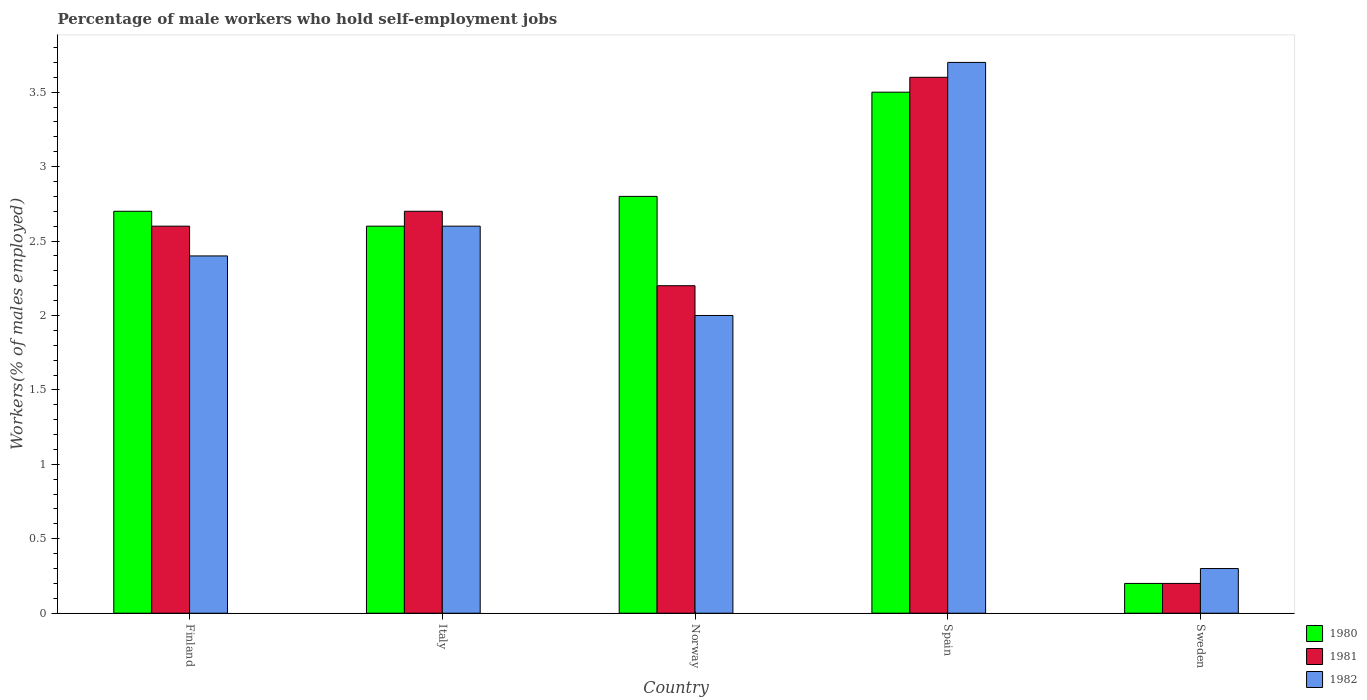How many groups of bars are there?
Your answer should be very brief. 5. In how many cases, is the number of bars for a given country not equal to the number of legend labels?
Keep it short and to the point. 0. What is the percentage of self-employed male workers in 1980 in Finland?
Your response must be concise. 2.7. Across all countries, what is the maximum percentage of self-employed male workers in 1982?
Offer a terse response. 3.7. Across all countries, what is the minimum percentage of self-employed male workers in 1980?
Offer a terse response. 0.2. In which country was the percentage of self-employed male workers in 1980 maximum?
Give a very brief answer. Spain. What is the total percentage of self-employed male workers in 1982 in the graph?
Keep it short and to the point. 11. What is the difference between the percentage of self-employed male workers in 1980 in Finland and that in Sweden?
Give a very brief answer. 2.5. What is the average percentage of self-employed male workers in 1980 per country?
Your answer should be very brief. 2.36. What is the ratio of the percentage of self-employed male workers in 1980 in Norway to that in Sweden?
Your response must be concise. 14. Is the difference between the percentage of self-employed male workers in 1980 in Finland and Norway greater than the difference between the percentage of self-employed male workers in 1982 in Finland and Norway?
Provide a short and direct response. No. What is the difference between the highest and the second highest percentage of self-employed male workers in 1982?
Provide a short and direct response. -1.1. What is the difference between the highest and the lowest percentage of self-employed male workers in 1982?
Your response must be concise. 3.4. In how many countries, is the percentage of self-employed male workers in 1981 greater than the average percentage of self-employed male workers in 1981 taken over all countries?
Your answer should be very brief. 3. Is the sum of the percentage of self-employed male workers in 1981 in Finland and Norway greater than the maximum percentage of self-employed male workers in 1980 across all countries?
Your response must be concise. Yes. Is it the case that in every country, the sum of the percentage of self-employed male workers in 1982 and percentage of self-employed male workers in 1981 is greater than the percentage of self-employed male workers in 1980?
Provide a succinct answer. Yes. How many bars are there?
Provide a short and direct response. 15. Are all the bars in the graph horizontal?
Make the answer very short. No. How many countries are there in the graph?
Your answer should be very brief. 5. What is the difference between two consecutive major ticks on the Y-axis?
Provide a succinct answer. 0.5. Are the values on the major ticks of Y-axis written in scientific E-notation?
Provide a short and direct response. No. Does the graph contain any zero values?
Provide a succinct answer. No. Does the graph contain grids?
Provide a short and direct response. No. Where does the legend appear in the graph?
Make the answer very short. Bottom right. What is the title of the graph?
Make the answer very short. Percentage of male workers who hold self-employment jobs. What is the label or title of the Y-axis?
Your response must be concise. Workers(% of males employed). What is the Workers(% of males employed) of 1980 in Finland?
Offer a very short reply. 2.7. What is the Workers(% of males employed) of 1981 in Finland?
Offer a very short reply. 2.6. What is the Workers(% of males employed) in 1982 in Finland?
Your answer should be very brief. 2.4. What is the Workers(% of males employed) of 1980 in Italy?
Provide a short and direct response. 2.6. What is the Workers(% of males employed) of 1981 in Italy?
Ensure brevity in your answer.  2.7. What is the Workers(% of males employed) in 1982 in Italy?
Give a very brief answer. 2.6. What is the Workers(% of males employed) in 1980 in Norway?
Your answer should be compact. 2.8. What is the Workers(% of males employed) in 1981 in Norway?
Your answer should be very brief. 2.2. What is the Workers(% of males employed) of 1982 in Norway?
Make the answer very short. 2. What is the Workers(% of males employed) in 1981 in Spain?
Your response must be concise. 3.6. What is the Workers(% of males employed) of 1982 in Spain?
Offer a terse response. 3.7. What is the Workers(% of males employed) in 1980 in Sweden?
Offer a very short reply. 0.2. What is the Workers(% of males employed) of 1981 in Sweden?
Give a very brief answer. 0.2. What is the Workers(% of males employed) of 1982 in Sweden?
Offer a very short reply. 0.3. Across all countries, what is the maximum Workers(% of males employed) of 1981?
Offer a very short reply. 3.6. Across all countries, what is the maximum Workers(% of males employed) in 1982?
Keep it short and to the point. 3.7. Across all countries, what is the minimum Workers(% of males employed) in 1980?
Make the answer very short. 0.2. Across all countries, what is the minimum Workers(% of males employed) of 1981?
Your answer should be compact. 0.2. Across all countries, what is the minimum Workers(% of males employed) of 1982?
Provide a short and direct response. 0.3. What is the total Workers(% of males employed) in 1980 in the graph?
Your answer should be very brief. 11.8. What is the total Workers(% of males employed) in 1982 in the graph?
Your answer should be compact. 11. What is the difference between the Workers(% of males employed) in 1981 in Finland and that in Italy?
Your answer should be compact. -0.1. What is the difference between the Workers(% of males employed) of 1980 in Finland and that in Norway?
Your response must be concise. -0.1. What is the difference between the Workers(% of males employed) in 1982 in Finland and that in Norway?
Offer a terse response. 0.4. What is the difference between the Workers(% of males employed) of 1980 in Finland and that in Spain?
Keep it short and to the point. -0.8. What is the difference between the Workers(% of males employed) of 1981 in Finland and that in Spain?
Your answer should be compact. -1. What is the difference between the Workers(% of males employed) in 1982 in Finland and that in Spain?
Your answer should be compact. -1.3. What is the difference between the Workers(% of males employed) of 1980 in Finland and that in Sweden?
Give a very brief answer. 2.5. What is the difference between the Workers(% of males employed) of 1981 in Finland and that in Sweden?
Provide a short and direct response. 2.4. What is the difference between the Workers(% of males employed) in 1982 in Finland and that in Sweden?
Make the answer very short. 2.1. What is the difference between the Workers(% of males employed) of 1981 in Italy and that in Norway?
Your answer should be very brief. 0.5. What is the difference between the Workers(% of males employed) in 1982 in Italy and that in Norway?
Your response must be concise. 0.6. What is the difference between the Workers(% of males employed) in 1980 in Italy and that in Spain?
Your answer should be compact. -0.9. What is the difference between the Workers(% of males employed) of 1981 in Italy and that in Spain?
Make the answer very short. -0.9. What is the difference between the Workers(% of males employed) of 1981 in Italy and that in Sweden?
Give a very brief answer. 2.5. What is the difference between the Workers(% of males employed) of 1981 in Norway and that in Spain?
Ensure brevity in your answer.  -1.4. What is the difference between the Workers(% of males employed) of 1982 in Norway and that in Spain?
Ensure brevity in your answer.  -1.7. What is the difference between the Workers(% of males employed) of 1981 in Norway and that in Sweden?
Your answer should be very brief. 2. What is the difference between the Workers(% of males employed) in 1981 in Spain and that in Sweden?
Provide a succinct answer. 3.4. What is the difference between the Workers(% of males employed) in 1982 in Spain and that in Sweden?
Your response must be concise. 3.4. What is the difference between the Workers(% of males employed) in 1981 in Finland and the Workers(% of males employed) in 1982 in Norway?
Provide a short and direct response. 0.6. What is the difference between the Workers(% of males employed) of 1980 in Finland and the Workers(% of males employed) of 1981 in Sweden?
Give a very brief answer. 2.5. What is the difference between the Workers(% of males employed) of 1981 in Finland and the Workers(% of males employed) of 1982 in Sweden?
Your answer should be very brief. 2.3. What is the difference between the Workers(% of males employed) of 1980 in Italy and the Workers(% of males employed) of 1981 in Norway?
Your answer should be compact. 0.4. What is the difference between the Workers(% of males employed) in 1980 in Italy and the Workers(% of males employed) in 1982 in Norway?
Your response must be concise. 0.6. What is the difference between the Workers(% of males employed) of 1980 in Italy and the Workers(% of males employed) of 1981 in Spain?
Keep it short and to the point. -1. What is the difference between the Workers(% of males employed) in 1981 in Italy and the Workers(% of males employed) in 1982 in Spain?
Offer a very short reply. -1. What is the difference between the Workers(% of males employed) of 1980 in Italy and the Workers(% of males employed) of 1981 in Sweden?
Provide a short and direct response. 2.4. What is the difference between the Workers(% of males employed) of 1980 in Norway and the Workers(% of males employed) of 1981 in Spain?
Make the answer very short. -0.8. What is the difference between the Workers(% of males employed) of 1980 in Norway and the Workers(% of males employed) of 1981 in Sweden?
Keep it short and to the point. 2.6. What is the difference between the Workers(% of males employed) of 1981 in Norway and the Workers(% of males employed) of 1982 in Sweden?
Provide a short and direct response. 1.9. What is the difference between the Workers(% of males employed) of 1980 in Spain and the Workers(% of males employed) of 1981 in Sweden?
Offer a terse response. 3.3. What is the difference between the Workers(% of males employed) of 1980 in Spain and the Workers(% of males employed) of 1982 in Sweden?
Ensure brevity in your answer.  3.2. What is the average Workers(% of males employed) in 1980 per country?
Keep it short and to the point. 2.36. What is the average Workers(% of males employed) of 1981 per country?
Your answer should be compact. 2.26. What is the average Workers(% of males employed) of 1982 per country?
Your response must be concise. 2.2. What is the difference between the Workers(% of males employed) of 1980 and Workers(% of males employed) of 1982 in Finland?
Offer a terse response. 0.3. What is the difference between the Workers(% of males employed) in 1980 and Workers(% of males employed) in 1981 in Italy?
Ensure brevity in your answer.  -0.1. What is the difference between the Workers(% of males employed) in 1981 and Workers(% of males employed) in 1982 in Italy?
Provide a short and direct response. 0.1. What is the difference between the Workers(% of males employed) in 1980 and Workers(% of males employed) in 1981 in Norway?
Offer a terse response. 0.6. What is the difference between the Workers(% of males employed) of 1981 and Workers(% of males employed) of 1982 in Norway?
Keep it short and to the point. 0.2. What is the difference between the Workers(% of males employed) in 1980 and Workers(% of males employed) in 1981 in Spain?
Your answer should be very brief. -0.1. What is the difference between the Workers(% of males employed) in 1980 and Workers(% of males employed) in 1982 in Spain?
Offer a terse response. -0.2. What is the difference between the Workers(% of males employed) in 1980 and Workers(% of males employed) in 1982 in Sweden?
Make the answer very short. -0.1. What is the ratio of the Workers(% of males employed) in 1981 in Finland to that in Italy?
Provide a short and direct response. 0.96. What is the ratio of the Workers(% of males employed) in 1981 in Finland to that in Norway?
Offer a very short reply. 1.18. What is the ratio of the Workers(% of males employed) of 1980 in Finland to that in Spain?
Provide a succinct answer. 0.77. What is the ratio of the Workers(% of males employed) in 1981 in Finland to that in Spain?
Your answer should be compact. 0.72. What is the ratio of the Workers(% of males employed) in 1982 in Finland to that in Spain?
Your response must be concise. 0.65. What is the ratio of the Workers(% of males employed) in 1981 in Italy to that in Norway?
Offer a terse response. 1.23. What is the ratio of the Workers(% of males employed) of 1980 in Italy to that in Spain?
Offer a terse response. 0.74. What is the ratio of the Workers(% of males employed) in 1981 in Italy to that in Spain?
Provide a short and direct response. 0.75. What is the ratio of the Workers(% of males employed) in 1982 in Italy to that in Spain?
Offer a terse response. 0.7. What is the ratio of the Workers(% of males employed) in 1982 in Italy to that in Sweden?
Give a very brief answer. 8.67. What is the ratio of the Workers(% of males employed) in 1981 in Norway to that in Spain?
Your answer should be compact. 0.61. What is the ratio of the Workers(% of males employed) of 1982 in Norway to that in Spain?
Provide a succinct answer. 0.54. What is the ratio of the Workers(% of males employed) of 1980 in Norway to that in Sweden?
Offer a very short reply. 14. What is the ratio of the Workers(% of males employed) in 1982 in Norway to that in Sweden?
Your response must be concise. 6.67. What is the ratio of the Workers(% of males employed) of 1980 in Spain to that in Sweden?
Give a very brief answer. 17.5. What is the ratio of the Workers(% of males employed) in 1982 in Spain to that in Sweden?
Keep it short and to the point. 12.33. What is the difference between the highest and the lowest Workers(% of males employed) in 1982?
Make the answer very short. 3.4. 